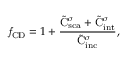<formula> <loc_0><loc_0><loc_500><loc_500>f _ { C D } = 1 + \frac { \tilde { C } _ { s c a } ^ { \sigma } + \tilde { C } _ { i n t } ^ { \sigma } } { \tilde { C } _ { i n c } ^ { \sigma } } ,</formula> 